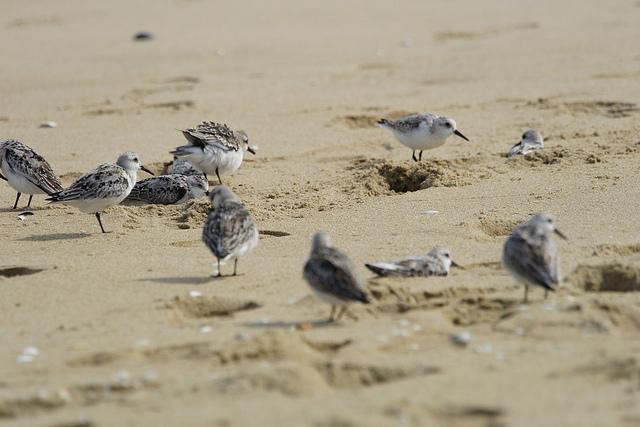How many birds can you see?
Give a very brief answer. 10. How many birds are there?
Give a very brief answer. 10. How many birds are visible?
Give a very brief answer. 8. How many people are to the left of the person standing?
Give a very brief answer. 0. 